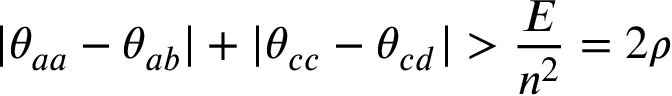Convert formula to latex. <formula><loc_0><loc_0><loc_500><loc_500>| \theta _ { a a } - \theta _ { a b } | + | \theta _ { c c } - \theta _ { c d } | > \frac { E } { n ^ { 2 } } = 2 \rho</formula> 